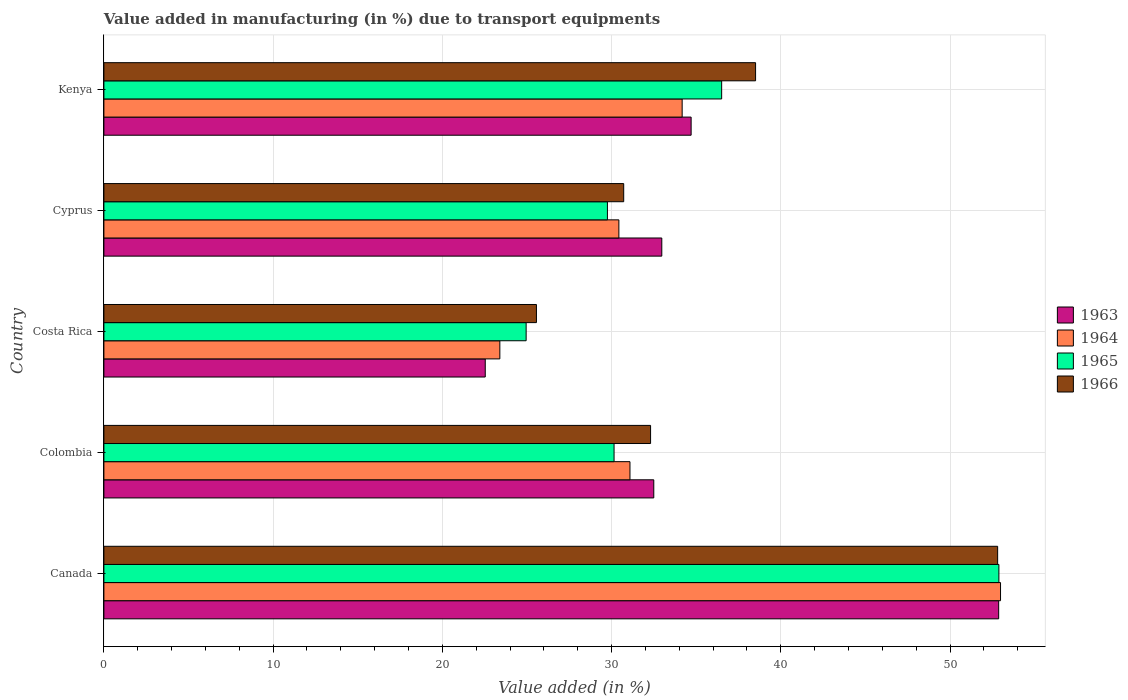How many different coloured bars are there?
Your response must be concise. 4. Are the number of bars per tick equal to the number of legend labels?
Your response must be concise. Yes. How many bars are there on the 5th tick from the top?
Provide a short and direct response. 4. How many bars are there on the 1st tick from the bottom?
Offer a very short reply. 4. What is the label of the 3rd group of bars from the top?
Your answer should be very brief. Costa Rica. What is the percentage of value added in manufacturing due to transport equipments in 1966 in Colombia?
Provide a succinct answer. 32.3. Across all countries, what is the maximum percentage of value added in manufacturing due to transport equipments in 1963?
Offer a terse response. 52.87. Across all countries, what is the minimum percentage of value added in manufacturing due to transport equipments in 1964?
Your answer should be very brief. 23.4. In which country was the percentage of value added in manufacturing due to transport equipments in 1966 minimum?
Your answer should be compact. Costa Rica. What is the total percentage of value added in manufacturing due to transport equipments in 1965 in the graph?
Your answer should be compact. 174.24. What is the difference between the percentage of value added in manufacturing due to transport equipments in 1965 in Canada and that in Cyprus?
Give a very brief answer. 23.13. What is the difference between the percentage of value added in manufacturing due to transport equipments in 1964 in Kenya and the percentage of value added in manufacturing due to transport equipments in 1965 in Cyprus?
Give a very brief answer. 4.42. What is the average percentage of value added in manufacturing due to transport equipments in 1963 per country?
Give a very brief answer. 35.11. What is the difference between the percentage of value added in manufacturing due to transport equipments in 1966 and percentage of value added in manufacturing due to transport equipments in 1964 in Colombia?
Your answer should be compact. 1.22. In how many countries, is the percentage of value added in manufacturing due to transport equipments in 1965 greater than 32 %?
Ensure brevity in your answer.  2. What is the ratio of the percentage of value added in manufacturing due to transport equipments in 1965 in Colombia to that in Kenya?
Make the answer very short. 0.83. Is the percentage of value added in manufacturing due to transport equipments in 1965 in Canada less than that in Kenya?
Make the answer very short. No. Is the difference between the percentage of value added in manufacturing due to transport equipments in 1966 in Canada and Colombia greater than the difference between the percentage of value added in manufacturing due to transport equipments in 1964 in Canada and Colombia?
Keep it short and to the point. No. What is the difference between the highest and the second highest percentage of value added in manufacturing due to transport equipments in 1966?
Ensure brevity in your answer.  14.3. What is the difference between the highest and the lowest percentage of value added in manufacturing due to transport equipments in 1964?
Make the answer very short. 29.59. In how many countries, is the percentage of value added in manufacturing due to transport equipments in 1966 greater than the average percentage of value added in manufacturing due to transport equipments in 1966 taken over all countries?
Ensure brevity in your answer.  2. Is the sum of the percentage of value added in manufacturing due to transport equipments in 1966 in Cyprus and Kenya greater than the maximum percentage of value added in manufacturing due to transport equipments in 1964 across all countries?
Make the answer very short. Yes. Is it the case that in every country, the sum of the percentage of value added in manufacturing due to transport equipments in 1963 and percentage of value added in manufacturing due to transport equipments in 1964 is greater than the sum of percentage of value added in manufacturing due to transport equipments in 1965 and percentage of value added in manufacturing due to transport equipments in 1966?
Give a very brief answer. No. What does the 3rd bar from the top in Canada represents?
Offer a terse response. 1964. What does the 4th bar from the bottom in Canada represents?
Provide a short and direct response. 1966. Are all the bars in the graph horizontal?
Offer a terse response. Yes. How many countries are there in the graph?
Offer a terse response. 5. What is the difference between two consecutive major ticks on the X-axis?
Provide a short and direct response. 10. Does the graph contain grids?
Your answer should be very brief. Yes. What is the title of the graph?
Your answer should be very brief. Value added in manufacturing (in %) due to transport equipments. What is the label or title of the X-axis?
Make the answer very short. Value added (in %). What is the label or title of the Y-axis?
Your response must be concise. Country. What is the Value added (in %) in 1963 in Canada?
Give a very brief answer. 52.87. What is the Value added (in %) in 1964 in Canada?
Provide a succinct answer. 52.98. What is the Value added (in %) in 1965 in Canada?
Ensure brevity in your answer.  52.89. What is the Value added (in %) in 1966 in Canada?
Ensure brevity in your answer.  52.81. What is the Value added (in %) in 1963 in Colombia?
Keep it short and to the point. 32.49. What is the Value added (in %) of 1964 in Colombia?
Provide a short and direct response. 31.09. What is the Value added (in %) of 1965 in Colombia?
Your answer should be compact. 30.15. What is the Value added (in %) of 1966 in Colombia?
Your response must be concise. 32.3. What is the Value added (in %) in 1963 in Costa Rica?
Offer a terse response. 22.53. What is the Value added (in %) of 1964 in Costa Rica?
Ensure brevity in your answer.  23.4. What is the Value added (in %) of 1965 in Costa Rica?
Your answer should be very brief. 24.95. What is the Value added (in %) of 1966 in Costa Rica?
Give a very brief answer. 25.56. What is the Value added (in %) of 1963 in Cyprus?
Offer a terse response. 32.97. What is the Value added (in %) of 1964 in Cyprus?
Make the answer very short. 30.43. What is the Value added (in %) of 1965 in Cyprus?
Your answer should be compact. 29.75. What is the Value added (in %) in 1966 in Cyprus?
Offer a terse response. 30.72. What is the Value added (in %) in 1963 in Kenya?
Keep it short and to the point. 34.7. What is the Value added (in %) in 1964 in Kenya?
Provide a short and direct response. 34.17. What is the Value added (in %) in 1965 in Kenya?
Provide a short and direct response. 36.5. What is the Value added (in %) of 1966 in Kenya?
Your answer should be very brief. 38.51. Across all countries, what is the maximum Value added (in %) of 1963?
Your answer should be compact. 52.87. Across all countries, what is the maximum Value added (in %) of 1964?
Offer a very short reply. 52.98. Across all countries, what is the maximum Value added (in %) in 1965?
Offer a very short reply. 52.89. Across all countries, what is the maximum Value added (in %) of 1966?
Give a very brief answer. 52.81. Across all countries, what is the minimum Value added (in %) of 1963?
Give a very brief answer. 22.53. Across all countries, what is the minimum Value added (in %) of 1964?
Offer a very short reply. 23.4. Across all countries, what is the minimum Value added (in %) of 1965?
Provide a succinct answer. 24.95. Across all countries, what is the minimum Value added (in %) in 1966?
Provide a short and direct response. 25.56. What is the total Value added (in %) of 1963 in the graph?
Offer a terse response. 175.57. What is the total Value added (in %) of 1964 in the graph?
Your response must be concise. 172.06. What is the total Value added (in %) in 1965 in the graph?
Your answer should be very brief. 174.24. What is the total Value added (in %) in 1966 in the graph?
Keep it short and to the point. 179.9. What is the difference between the Value added (in %) of 1963 in Canada and that in Colombia?
Offer a very short reply. 20.38. What is the difference between the Value added (in %) in 1964 in Canada and that in Colombia?
Your answer should be compact. 21.9. What is the difference between the Value added (in %) in 1965 in Canada and that in Colombia?
Your answer should be very brief. 22.74. What is the difference between the Value added (in %) of 1966 in Canada and that in Colombia?
Your answer should be compact. 20.51. What is the difference between the Value added (in %) in 1963 in Canada and that in Costa Rica?
Ensure brevity in your answer.  30.34. What is the difference between the Value added (in %) in 1964 in Canada and that in Costa Rica?
Provide a short and direct response. 29.59. What is the difference between the Value added (in %) in 1965 in Canada and that in Costa Rica?
Provide a short and direct response. 27.93. What is the difference between the Value added (in %) of 1966 in Canada and that in Costa Rica?
Offer a terse response. 27.25. What is the difference between the Value added (in %) of 1963 in Canada and that in Cyprus?
Your answer should be compact. 19.91. What is the difference between the Value added (in %) of 1964 in Canada and that in Cyprus?
Your answer should be compact. 22.55. What is the difference between the Value added (in %) of 1965 in Canada and that in Cyprus?
Your answer should be very brief. 23.13. What is the difference between the Value added (in %) of 1966 in Canada and that in Cyprus?
Offer a very short reply. 22.1. What is the difference between the Value added (in %) in 1963 in Canada and that in Kenya?
Provide a succinct answer. 18.17. What is the difference between the Value added (in %) of 1964 in Canada and that in Kenya?
Make the answer very short. 18.81. What is the difference between the Value added (in %) of 1965 in Canada and that in Kenya?
Offer a terse response. 16.38. What is the difference between the Value added (in %) of 1966 in Canada and that in Kenya?
Provide a succinct answer. 14.3. What is the difference between the Value added (in %) of 1963 in Colombia and that in Costa Rica?
Keep it short and to the point. 9.96. What is the difference between the Value added (in %) in 1964 in Colombia and that in Costa Rica?
Your answer should be very brief. 7.69. What is the difference between the Value added (in %) in 1965 in Colombia and that in Costa Rica?
Provide a short and direct response. 5.2. What is the difference between the Value added (in %) of 1966 in Colombia and that in Costa Rica?
Keep it short and to the point. 6.74. What is the difference between the Value added (in %) of 1963 in Colombia and that in Cyprus?
Offer a terse response. -0.47. What is the difference between the Value added (in %) in 1964 in Colombia and that in Cyprus?
Offer a very short reply. 0.66. What is the difference between the Value added (in %) of 1965 in Colombia and that in Cyprus?
Offer a very short reply. 0.39. What is the difference between the Value added (in %) in 1966 in Colombia and that in Cyprus?
Keep it short and to the point. 1.59. What is the difference between the Value added (in %) of 1963 in Colombia and that in Kenya?
Offer a very short reply. -2.21. What is the difference between the Value added (in %) of 1964 in Colombia and that in Kenya?
Give a very brief answer. -3.08. What is the difference between the Value added (in %) in 1965 in Colombia and that in Kenya?
Offer a very short reply. -6.36. What is the difference between the Value added (in %) of 1966 in Colombia and that in Kenya?
Your answer should be compact. -6.2. What is the difference between the Value added (in %) of 1963 in Costa Rica and that in Cyprus?
Ensure brevity in your answer.  -10.43. What is the difference between the Value added (in %) in 1964 in Costa Rica and that in Cyprus?
Ensure brevity in your answer.  -7.03. What is the difference between the Value added (in %) of 1965 in Costa Rica and that in Cyprus?
Offer a terse response. -4.8. What is the difference between the Value added (in %) in 1966 in Costa Rica and that in Cyprus?
Offer a very short reply. -5.16. What is the difference between the Value added (in %) in 1963 in Costa Rica and that in Kenya?
Offer a terse response. -12.17. What is the difference between the Value added (in %) in 1964 in Costa Rica and that in Kenya?
Give a very brief answer. -10.77. What is the difference between the Value added (in %) of 1965 in Costa Rica and that in Kenya?
Keep it short and to the point. -11.55. What is the difference between the Value added (in %) in 1966 in Costa Rica and that in Kenya?
Offer a terse response. -12.95. What is the difference between the Value added (in %) of 1963 in Cyprus and that in Kenya?
Provide a succinct answer. -1.73. What is the difference between the Value added (in %) in 1964 in Cyprus and that in Kenya?
Your answer should be compact. -3.74. What is the difference between the Value added (in %) of 1965 in Cyprus and that in Kenya?
Your answer should be very brief. -6.75. What is the difference between the Value added (in %) of 1966 in Cyprus and that in Kenya?
Your response must be concise. -7.79. What is the difference between the Value added (in %) in 1963 in Canada and the Value added (in %) in 1964 in Colombia?
Your answer should be compact. 21.79. What is the difference between the Value added (in %) of 1963 in Canada and the Value added (in %) of 1965 in Colombia?
Make the answer very short. 22.73. What is the difference between the Value added (in %) in 1963 in Canada and the Value added (in %) in 1966 in Colombia?
Offer a very short reply. 20.57. What is the difference between the Value added (in %) in 1964 in Canada and the Value added (in %) in 1965 in Colombia?
Your answer should be compact. 22.84. What is the difference between the Value added (in %) in 1964 in Canada and the Value added (in %) in 1966 in Colombia?
Offer a very short reply. 20.68. What is the difference between the Value added (in %) of 1965 in Canada and the Value added (in %) of 1966 in Colombia?
Offer a very short reply. 20.58. What is the difference between the Value added (in %) in 1963 in Canada and the Value added (in %) in 1964 in Costa Rica?
Offer a terse response. 29.48. What is the difference between the Value added (in %) of 1963 in Canada and the Value added (in %) of 1965 in Costa Rica?
Make the answer very short. 27.92. What is the difference between the Value added (in %) in 1963 in Canada and the Value added (in %) in 1966 in Costa Rica?
Offer a terse response. 27.31. What is the difference between the Value added (in %) in 1964 in Canada and the Value added (in %) in 1965 in Costa Rica?
Offer a terse response. 28.03. What is the difference between the Value added (in %) of 1964 in Canada and the Value added (in %) of 1966 in Costa Rica?
Provide a succinct answer. 27.42. What is the difference between the Value added (in %) of 1965 in Canada and the Value added (in %) of 1966 in Costa Rica?
Make the answer very short. 27.33. What is the difference between the Value added (in %) in 1963 in Canada and the Value added (in %) in 1964 in Cyprus?
Make the answer very short. 22.44. What is the difference between the Value added (in %) of 1963 in Canada and the Value added (in %) of 1965 in Cyprus?
Keep it short and to the point. 23.12. What is the difference between the Value added (in %) of 1963 in Canada and the Value added (in %) of 1966 in Cyprus?
Keep it short and to the point. 22.16. What is the difference between the Value added (in %) in 1964 in Canada and the Value added (in %) in 1965 in Cyprus?
Make the answer very short. 23.23. What is the difference between the Value added (in %) in 1964 in Canada and the Value added (in %) in 1966 in Cyprus?
Your answer should be compact. 22.27. What is the difference between the Value added (in %) in 1965 in Canada and the Value added (in %) in 1966 in Cyprus?
Give a very brief answer. 22.17. What is the difference between the Value added (in %) of 1963 in Canada and the Value added (in %) of 1964 in Kenya?
Keep it short and to the point. 18.7. What is the difference between the Value added (in %) of 1963 in Canada and the Value added (in %) of 1965 in Kenya?
Keep it short and to the point. 16.37. What is the difference between the Value added (in %) of 1963 in Canada and the Value added (in %) of 1966 in Kenya?
Give a very brief answer. 14.37. What is the difference between the Value added (in %) of 1964 in Canada and the Value added (in %) of 1965 in Kenya?
Give a very brief answer. 16.48. What is the difference between the Value added (in %) in 1964 in Canada and the Value added (in %) in 1966 in Kenya?
Ensure brevity in your answer.  14.47. What is the difference between the Value added (in %) of 1965 in Canada and the Value added (in %) of 1966 in Kenya?
Ensure brevity in your answer.  14.38. What is the difference between the Value added (in %) of 1963 in Colombia and the Value added (in %) of 1964 in Costa Rica?
Your response must be concise. 9.1. What is the difference between the Value added (in %) of 1963 in Colombia and the Value added (in %) of 1965 in Costa Rica?
Offer a very short reply. 7.54. What is the difference between the Value added (in %) of 1963 in Colombia and the Value added (in %) of 1966 in Costa Rica?
Offer a terse response. 6.93. What is the difference between the Value added (in %) of 1964 in Colombia and the Value added (in %) of 1965 in Costa Rica?
Keep it short and to the point. 6.14. What is the difference between the Value added (in %) of 1964 in Colombia and the Value added (in %) of 1966 in Costa Rica?
Your answer should be very brief. 5.53. What is the difference between the Value added (in %) of 1965 in Colombia and the Value added (in %) of 1966 in Costa Rica?
Keep it short and to the point. 4.59. What is the difference between the Value added (in %) of 1963 in Colombia and the Value added (in %) of 1964 in Cyprus?
Offer a very short reply. 2.06. What is the difference between the Value added (in %) in 1963 in Colombia and the Value added (in %) in 1965 in Cyprus?
Ensure brevity in your answer.  2.74. What is the difference between the Value added (in %) of 1963 in Colombia and the Value added (in %) of 1966 in Cyprus?
Provide a short and direct response. 1.78. What is the difference between the Value added (in %) of 1964 in Colombia and the Value added (in %) of 1965 in Cyprus?
Keep it short and to the point. 1.33. What is the difference between the Value added (in %) of 1964 in Colombia and the Value added (in %) of 1966 in Cyprus?
Keep it short and to the point. 0.37. What is the difference between the Value added (in %) in 1965 in Colombia and the Value added (in %) in 1966 in Cyprus?
Give a very brief answer. -0.57. What is the difference between the Value added (in %) of 1963 in Colombia and the Value added (in %) of 1964 in Kenya?
Provide a short and direct response. -1.68. What is the difference between the Value added (in %) of 1963 in Colombia and the Value added (in %) of 1965 in Kenya?
Your response must be concise. -4.01. What is the difference between the Value added (in %) of 1963 in Colombia and the Value added (in %) of 1966 in Kenya?
Your answer should be very brief. -6.01. What is the difference between the Value added (in %) of 1964 in Colombia and the Value added (in %) of 1965 in Kenya?
Ensure brevity in your answer.  -5.42. What is the difference between the Value added (in %) of 1964 in Colombia and the Value added (in %) of 1966 in Kenya?
Ensure brevity in your answer.  -7.42. What is the difference between the Value added (in %) in 1965 in Colombia and the Value added (in %) in 1966 in Kenya?
Offer a very short reply. -8.36. What is the difference between the Value added (in %) in 1963 in Costa Rica and the Value added (in %) in 1964 in Cyprus?
Make the answer very short. -7.9. What is the difference between the Value added (in %) in 1963 in Costa Rica and the Value added (in %) in 1965 in Cyprus?
Provide a succinct answer. -7.22. What is the difference between the Value added (in %) of 1963 in Costa Rica and the Value added (in %) of 1966 in Cyprus?
Your answer should be compact. -8.18. What is the difference between the Value added (in %) in 1964 in Costa Rica and the Value added (in %) in 1965 in Cyprus?
Ensure brevity in your answer.  -6.36. What is the difference between the Value added (in %) of 1964 in Costa Rica and the Value added (in %) of 1966 in Cyprus?
Ensure brevity in your answer.  -7.32. What is the difference between the Value added (in %) of 1965 in Costa Rica and the Value added (in %) of 1966 in Cyprus?
Give a very brief answer. -5.77. What is the difference between the Value added (in %) in 1963 in Costa Rica and the Value added (in %) in 1964 in Kenya?
Your answer should be very brief. -11.64. What is the difference between the Value added (in %) of 1963 in Costa Rica and the Value added (in %) of 1965 in Kenya?
Provide a short and direct response. -13.97. What is the difference between the Value added (in %) of 1963 in Costa Rica and the Value added (in %) of 1966 in Kenya?
Your answer should be very brief. -15.97. What is the difference between the Value added (in %) in 1964 in Costa Rica and the Value added (in %) in 1965 in Kenya?
Provide a short and direct response. -13.11. What is the difference between the Value added (in %) of 1964 in Costa Rica and the Value added (in %) of 1966 in Kenya?
Provide a short and direct response. -15.11. What is the difference between the Value added (in %) of 1965 in Costa Rica and the Value added (in %) of 1966 in Kenya?
Offer a terse response. -13.56. What is the difference between the Value added (in %) of 1963 in Cyprus and the Value added (in %) of 1964 in Kenya?
Your answer should be compact. -1.2. What is the difference between the Value added (in %) in 1963 in Cyprus and the Value added (in %) in 1965 in Kenya?
Your answer should be compact. -3.54. What is the difference between the Value added (in %) in 1963 in Cyprus and the Value added (in %) in 1966 in Kenya?
Provide a succinct answer. -5.54. What is the difference between the Value added (in %) of 1964 in Cyprus and the Value added (in %) of 1965 in Kenya?
Give a very brief answer. -6.07. What is the difference between the Value added (in %) in 1964 in Cyprus and the Value added (in %) in 1966 in Kenya?
Your response must be concise. -8.08. What is the difference between the Value added (in %) in 1965 in Cyprus and the Value added (in %) in 1966 in Kenya?
Give a very brief answer. -8.75. What is the average Value added (in %) of 1963 per country?
Provide a succinct answer. 35.11. What is the average Value added (in %) in 1964 per country?
Give a very brief answer. 34.41. What is the average Value added (in %) of 1965 per country?
Offer a very short reply. 34.85. What is the average Value added (in %) in 1966 per country?
Offer a terse response. 35.98. What is the difference between the Value added (in %) in 1963 and Value added (in %) in 1964 in Canada?
Your answer should be compact. -0.11. What is the difference between the Value added (in %) in 1963 and Value added (in %) in 1965 in Canada?
Your answer should be compact. -0.01. What is the difference between the Value added (in %) in 1963 and Value added (in %) in 1966 in Canada?
Offer a very short reply. 0.06. What is the difference between the Value added (in %) in 1964 and Value added (in %) in 1965 in Canada?
Give a very brief answer. 0.1. What is the difference between the Value added (in %) in 1964 and Value added (in %) in 1966 in Canada?
Your answer should be very brief. 0.17. What is the difference between the Value added (in %) of 1965 and Value added (in %) of 1966 in Canada?
Ensure brevity in your answer.  0.07. What is the difference between the Value added (in %) in 1963 and Value added (in %) in 1964 in Colombia?
Give a very brief answer. 1.41. What is the difference between the Value added (in %) of 1963 and Value added (in %) of 1965 in Colombia?
Ensure brevity in your answer.  2.35. What is the difference between the Value added (in %) of 1963 and Value added (in %) of 1966 in Colombia?
Keep it short and to the point. 0.19. What is the difference between the Value added (in %) in 1964 and Value added (in %) in 1965 in Colombia?
Your answer should be very brief. 0.94. What is the difference between the Value added (in %) in 1964 and Value added (in %) in 1966 in Colombia?
Offer a terse response. -1.22. What is the difference between the Value added (in %) in 1965 and Value added (in %) in 1966 in Colombia?
Offer a very short reply. -2.16. What is the difference between the Value added (in %) in 1963 and Value added (in %) in 1964 in Costa Rica?
Give a very brief answer. -0.86. What is the difference between the Value added (in %) in 1963 and Value added (in %) in 1965 in Costa Rica?
Provide a short and direct response. -2.42. What is the difference between the Value added (in %) in 1963 and Value added (in %) in 1966 in Costa Rica?
Offer a very short reply. -3.03. What is the difference between the Value added (in %) in 1964 and Value added (in %) in 1965 in Costa Rica?
Offer a terse response. -1.55. What is the difference between the Value added (in %) of 1964 and Value added (in %) of 1966 in Costa Rica?
Your answer should be compact. -2.16. What is the difference between the Value added (in %) in 1965 and Value added (in %) in 1966 in Costa Rica?
Give a very brief answer. -0.61. What is the difference between the Value added (in %) of 1963 and Value added (in %) of 1964 in Cyprus?
Offer a terse response. 2.54. What is the difference between the Value added (in %) in 1963 and Value added (in %) in 1965 in Cyprus?
Make the answer very short. 3.21. What is the difference between the Value added (in %) of 1963 and Value added (in %) of 1966 in Cyprus?
Offer a terse response. 2.25. What is the difference between the Value added (in %) of 1964 and Value added (in %) of 1965 in Cyprus?
Provide a succinct answer. 0.68. What is the difference between the Value added (in %) of 1964 and Value added (in %) of 1966 in Cyprus?
Provide a short and direct response. -0.29. What is the difference between the Value added (in %) in 1965 and Value added (in %) in 1966 in Cyprus?
Ensure brevity in your answer.  -0.96. What is the difference between the Value added (in %) of 1963 and Value added (in %) of 1964 in Kenya?
Your answer should be very brief. 0.53. What is the difference between the Value added (in %) of 1963 and Value added (in %) of 1965 in Kenya?
Your response must be concise. -1.8. What is the difference between the Value added (in %) of 1963 and Value added (in %) of 1966 in Kenya?
Offer a terse response. -3.81. What is the difference between the Value added (in %) in 1964 and Value added (in %) in 1965 in Kenya?
Ensure brevity in your answer.  -2.33. What is the difference between the Value added (in %) in 1964 and Value added (in %) in 1966 in Kenya?
Provide a succinct answer. -4.34. What is the difference between the Value added (in %) of 1965 and Value added (in %) of 1966 in Kenya?
Offer a very short reply. -2. What is the ratio of the Value added (in %) in 1963 in Canada to that in Colombia?
Your answer should be very brief. 1.63. What is the ratio of the Value added (in %) in 1964 in Canada to that in Colombia?
Provide a short and direct response. 1.7. What is the ratio of the Value added (in %) in 1965 in Canada to that in Colombia?
Your answer should be compact. 1.75. What is the ratio of the Value added (in %) of 1966 in Canada to that in Colombia?
Your response must be concise. 1.63. What is the ratio of the Value added (in %) in 1963 in Canada to that in Costa Rica?
Offer a very short reply. 2.35. What is the ratio of the Value added (in %) of 1964 in Canada to that in Costa Rica?
Provide a succinct answer. 2.26. What is the ratio of the Value added (in %) of 1965 in Canada to that in Costa Rica?
Your response must be concise. 2.12. What is the ratio of the Value added (in %) of 1966 in Canada to that in Costa Rica?
Your answer should be compact. 2.07. What is the ratio of the Value added (in %) of 1963 in Canada to that in Cyprus?
Your response must be concise. 1.6. What is the ratio of the Value added (in %) of 1964 in Canada to that in Cyprus?
Provide a succinct answer. 1.74. What is the ratio of the Value added (in %) in 1965 in Canada to that in Cyprus?
Your response must be concise. 1.78. What is the ratio of the Value added (in %) of 1966 in Canada to that in Cyprus?
Your answer should be compact. 1.72. What is the ratio of the Value added (in %) of 1963 in Canada to that in Kenya?
Make the answer very short. 1.52. What is the ratio of the Value added (in %) in 1964 in Canada to that in Kenya?
Keep it short and to the point. 1.55. What is the ratio of the Value added (in %) in 1965 in Canada to that in Kenya?
Give a very brief answer. 1.45. What is the ratio of the Value added (in %) in 1966 in Canada to that in Kenya?
Your answer should be very brief. 1.37. What is the ratio of the Value added (in %) of 1963 in Colombia to that in Costa Rica?
Ensure brevity in your answer.  1.44. What is the ratio of the Value added (in %) of 1964 in Colombia to that in Costa Rica?
Your answer should be compact. 1.33. What is the ratio of the Value added (in %) in 1965 in Colombia to that in Costa Rica?
Provide a succinct answer. 1.21. What is the ratio of the Value added (in %) in 1966 in Colombia to that in Costa Rica?
Give a very brief answer. 1.26. What is the ratio of the Value added (in %) of 1963 in Colombia to that in Cyprus?
Keep it short and to the point. 0.99. What is the ratio of the Value added (in %) in 1964 in Colombia to that in Cyprus?
Your answer should be compact. 1.02. What is the ratio of the Value added (in %) of 1965 in Colombia to that in Cyprus?
Provide a succinct answer. 1.01. What is the ratio of the Value added (in %) of 1966 in Colombia to that in Cyprus?
Your response must be concise. 1.05. What is the ratio of the Value added (in %) of 1963 in Colombia to that in Kenya?
Keep it short and to the point. 0.94. What is the ratio of the Value added (in %) of 1964 in Colombia to that in Kenya?
Offer a very short reply. 0.91. What is the ratio of the Value added (in %) of 1965 in Colombia to that in Kenya?
Offer a terse response. 0.83. What is the ratio of the Value added (in %) of 1966 in Colombia to that in Kenya?
Your answer should be compact. 0.84. What is the ratio of the Value added (in %) of 1963 in Costa Rica to that in Cyprus?
Give a very brief answer. 0.68. What is the ratio of the Value added (in %) in 1964 in Costa Rica to that in Cyprus?
Give a very brief answer. 0.77. What is the ratio of the Value added (in %) in 1965 in Costa Rica to that in Cyprus?
Provide a succinct answer. 0.84. What is the ratio of the Value added (in %) of 1966 in Costa Rica to that in Cyprus?
Your response must be concise. 0.83. What is the ratio of the Value added (in %) in 1963 in Costa Rica to that in Kenya?
Make the answer very short. 0.65. What is the ratio of the Value added (in %) of 1964 in Costa Rica to that in Kenya?
Keep it short and to the point. 0.68. What is the ratio of the Value added (in %) in 1965 in Costa Rica to that in Kenya?
Provide a succinct answer. 0.68. What is the ratio of the Value added (in %) of 1966 in Costa Rica to that in Kenya?
Offer a terse response. 0.66. What is the ratio of the Value added (in %) in 1963 in Cyprus to that in Kenya?
Your answer should be very brief. 0.95. What is the ratio of the Value added (in %) of 1964 in Cyprus to that in Kenya?
Provide a short and direct response. 0.89. What is the ratio of the Value added (in %) of 1965 in Cyprus to that in Kenya?
Give a very brief answer. 0.82. What is the ratio of the Value added (in %) in 1966 in Cyprus to that in Kenya?
Give a very brief answer. 0.8. What is the difference between the highest and the second highest Value added (in %) of 1963?
Provide a succinct answer. 18.17. What is the difference between the highest and the second highest Value added (in %) in 1964?
Your answer should be compact. 18.81. What is the difference between the highest and the second highest Value added (in %) of 1965?
Your answer should be compact. 16.38. What is the difference between the highest and the second highest Value added (in %) of 1966?
Your response must be concise. 14.3. What is the difference between the highest and the lowest Value added (in %) of 1963?
Ensure brevity in your answer.  30.34. What is the difference between the highest and the lowest Value added (in %) of 1964?
Ensure brevity in your answer.  29.59. What is the difference between the highest and the lowest Value added (in %) in 1965?
Ensure brevity in your answer.  27.93. What is the difference between the highest and the lowest Value added (in %) of 1966?
Your answer should be very brief. 27.25. 